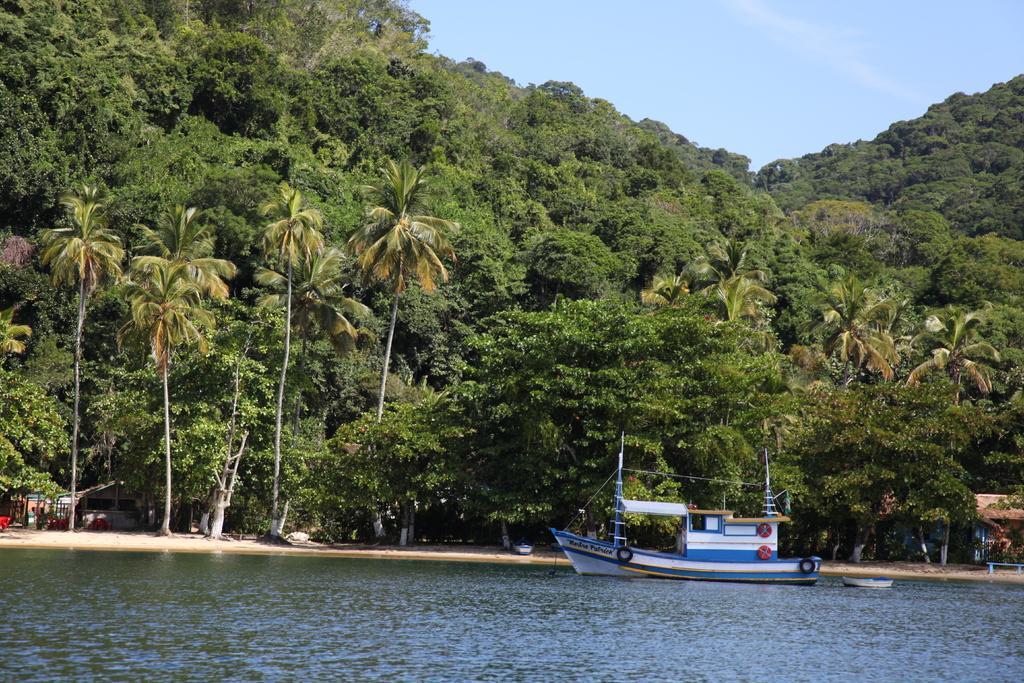Can you describe this image briefly? In this image on the water body there is a boat. In the background there are trees, buildings, hills. The sky is clear. 